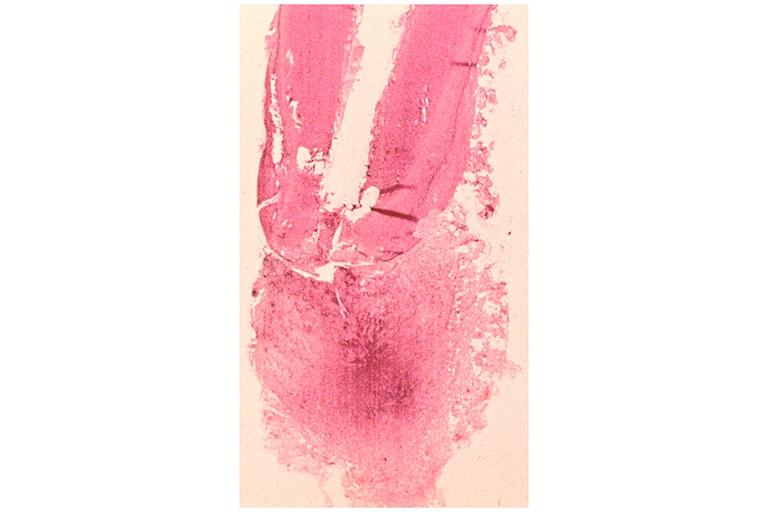what does this image show?
Answer the question using a single word or phrase. Periapical granuloma 